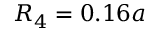<formula> <loc_0><loc_0><loc_500><loc_500>R _ { 4 } = 0 . 1 6 a</formula> 